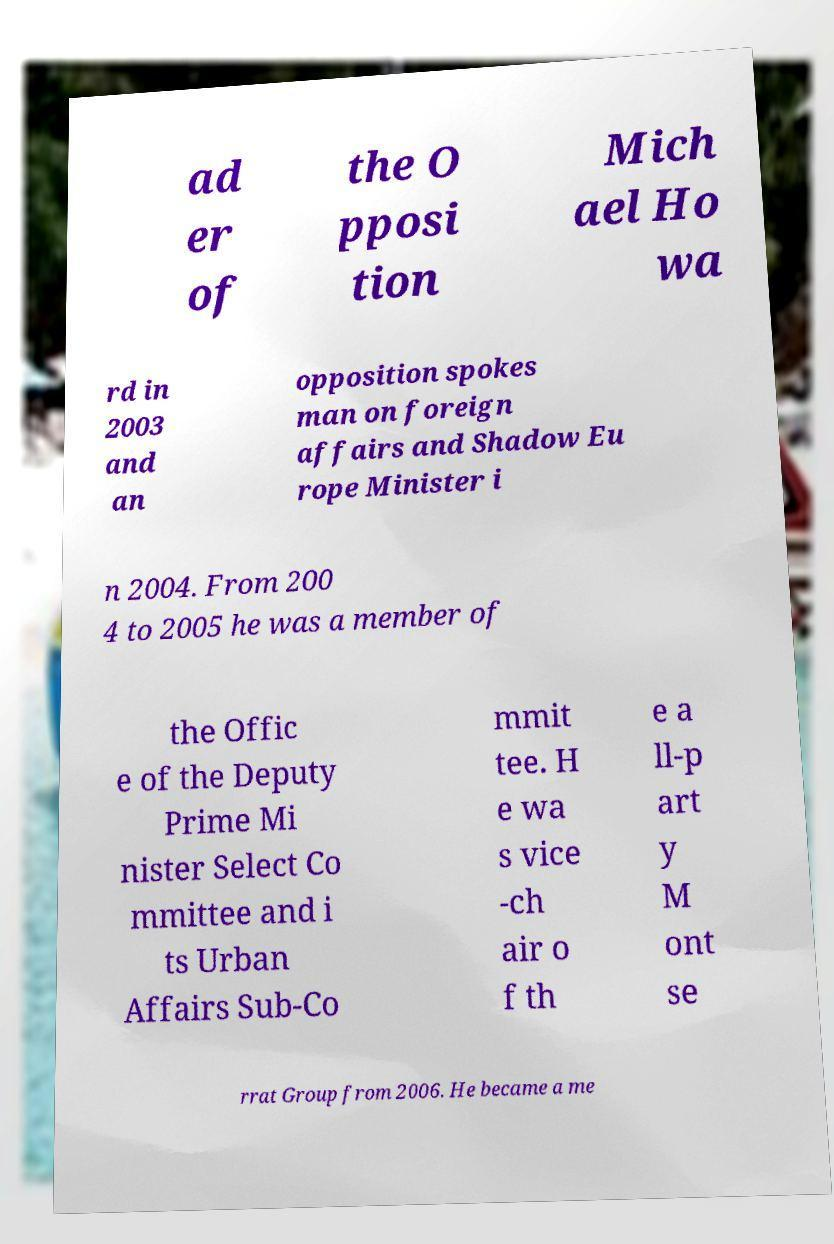Can you read and provide the text displayed in the image?This photo seems to have some interesting text. Can you extract and type it out for me? ad er of the O pposi tion Mich ael Ho wa rd in 2003 and an opposition spokes man on foreign affairs and Shadow Eu rope Minister i n 2004. From 200 4 to 2005 he was a member of the Offic e of the Deputy Prime Mi nister Select Co mmittee and i ts Urban Affairs Sub-Co mmit tee. H e wa s vice -ch air o f th e a ll-p art y M ont se rrat Group from 2006. He became a me 